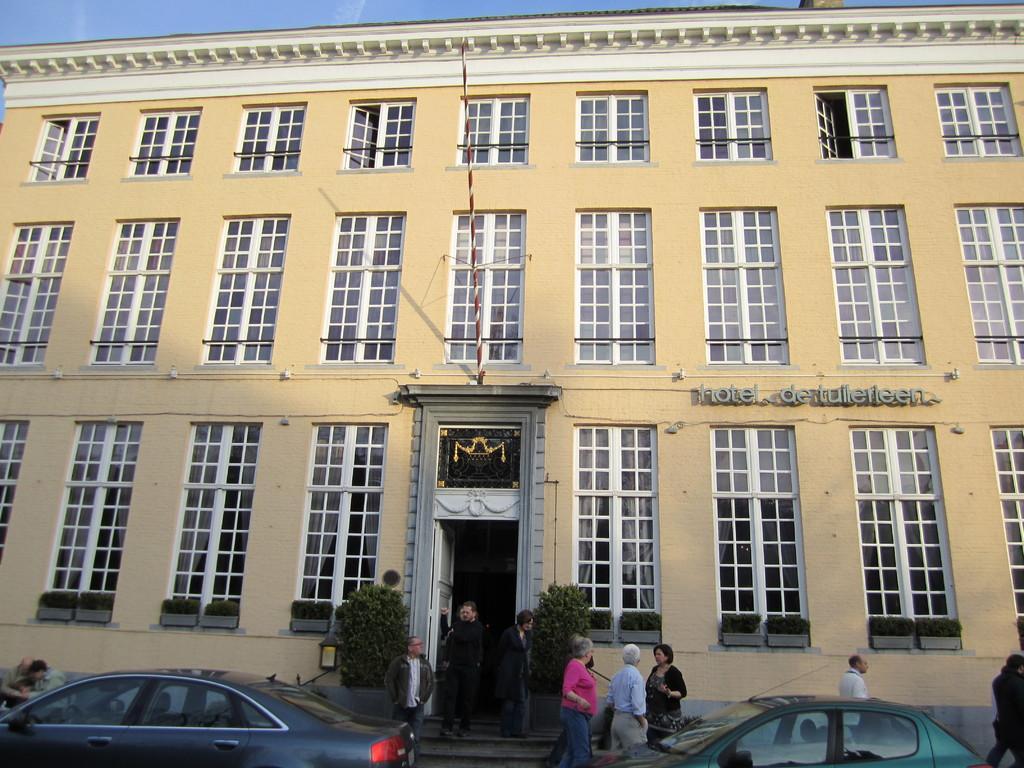Please provide a concise description of this image. In this picture there are people and we can see cars, plants, pole and windows. We can see text on the wall. In the background of the image we can see the sky. 